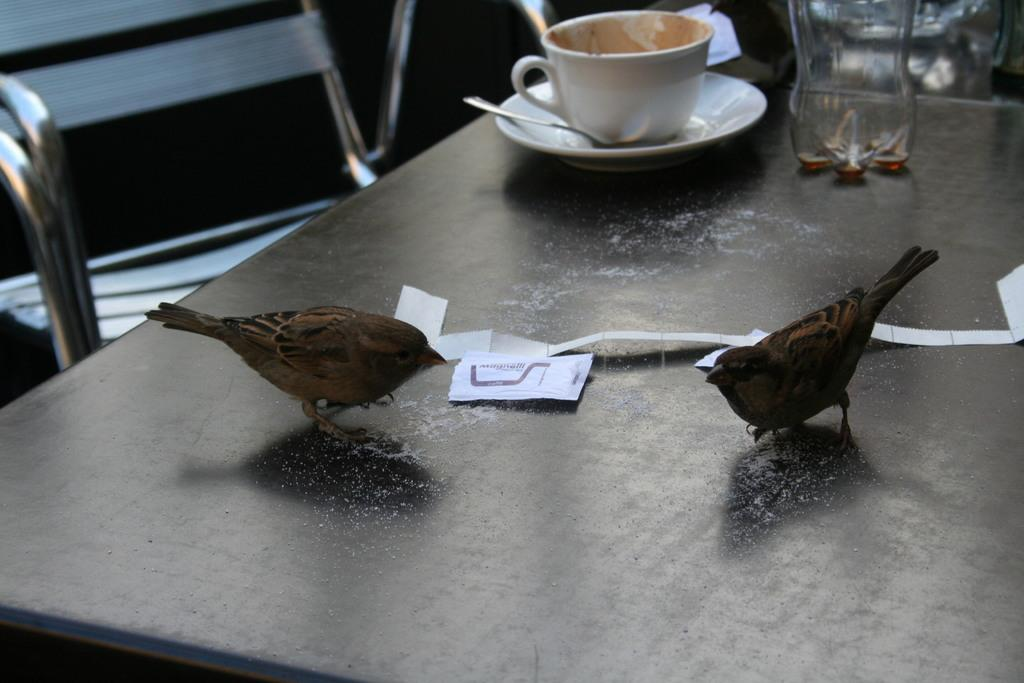What is the main object in the image? There is a table in the image. What animals can be seen on the table? There are two birds on the table. What other items are present on the table? There is a cup, a fork, a saucer, and a bottle on the table. What type of song is being sung by the lizards in the image? There are no lizards present in the image, so there is no song being sung. 